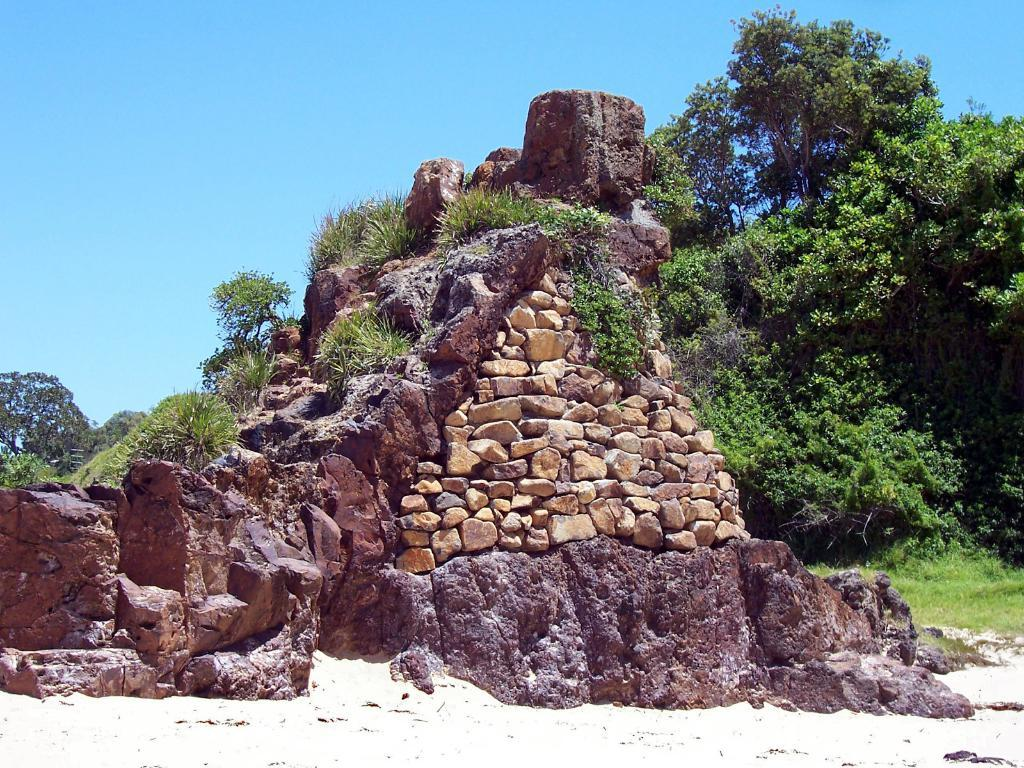What type of natural elements can be seen in the image? There are stones, rocks, plants, and trees visible in the image. What is the ground like in the image? The ground is visible in the image. What part of the natural environment is visible in the image? The sky is visible in the image. What type of mint can be seen growing among the rocks in the image? There is no mint present in the image; it only features stones, rocks, plants, and trees. 